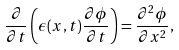<formula> <loc_0><loc_0><loc_500><loc_500>\frac { \partial } { \partial t } \left ( \epsilon ( x , t ) \frac { \partial \phi } { \partial t } \right ) = \frac { \partial ^ { 2 } \phi } { \partial x ^ { 2 } } ,</formula> 